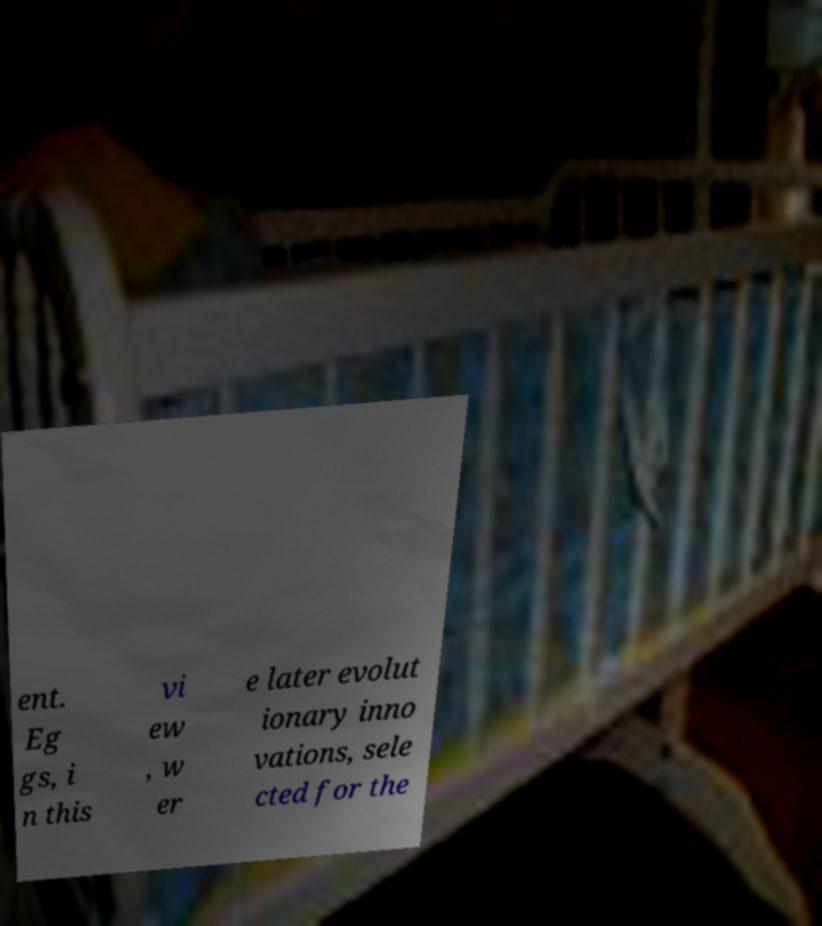Could you extract and type out the text from this image? ent. Eg gs, i n this vi ew , w er e later evolut ionary inno vations, sele cted for the 